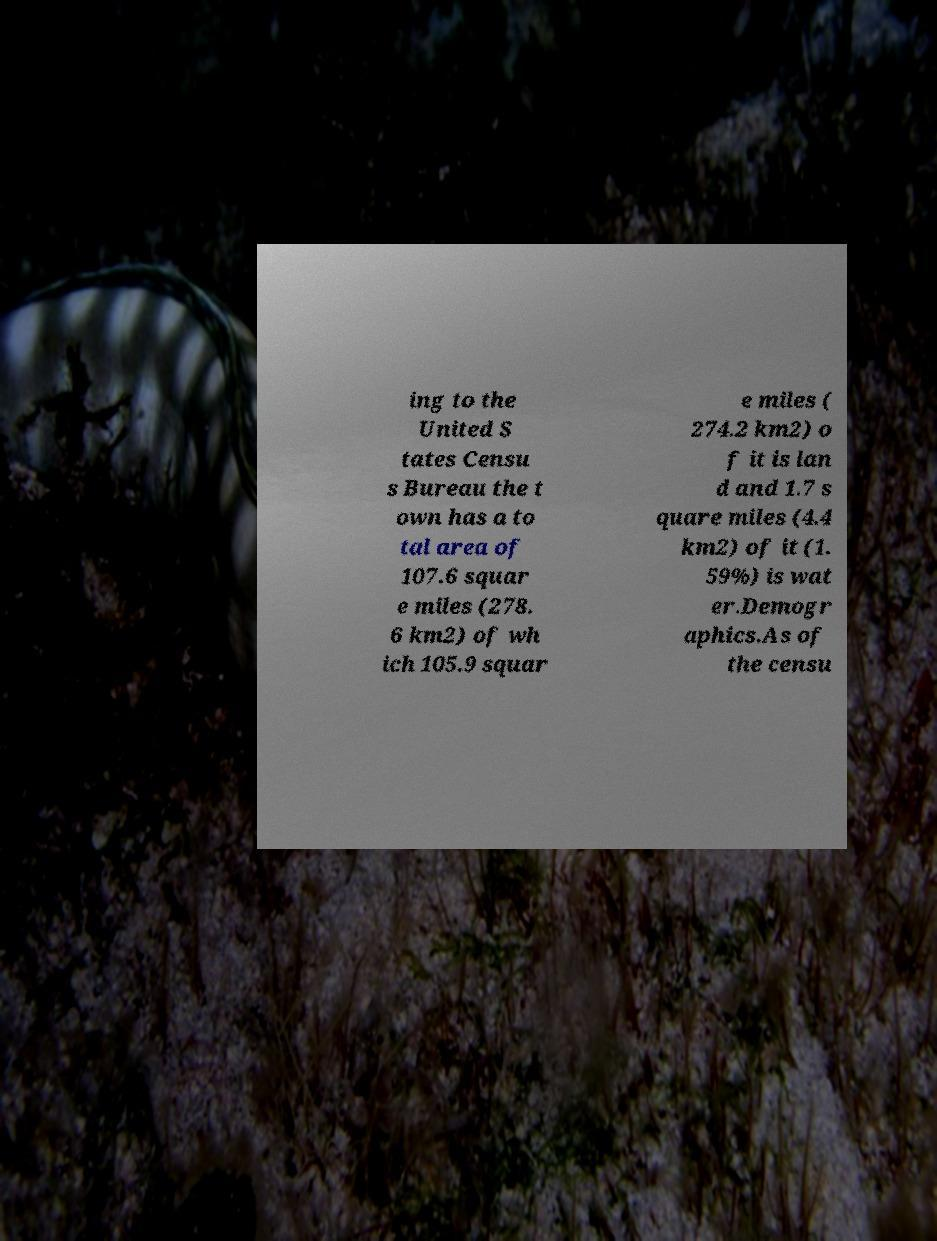Please identify and transcribe the text found in this image. ing to the United S tates Censu s Bureau the t own has a to tal area of 107.6 squar e miles (278. 6 km2) of wh ich 105.9 squar e miles ( 274.2 km2) o f it is lan d and 1.7 s quare miles (4.4 km2) of it (1. 59%) is wat er.Demogr aphics.As of the censu 